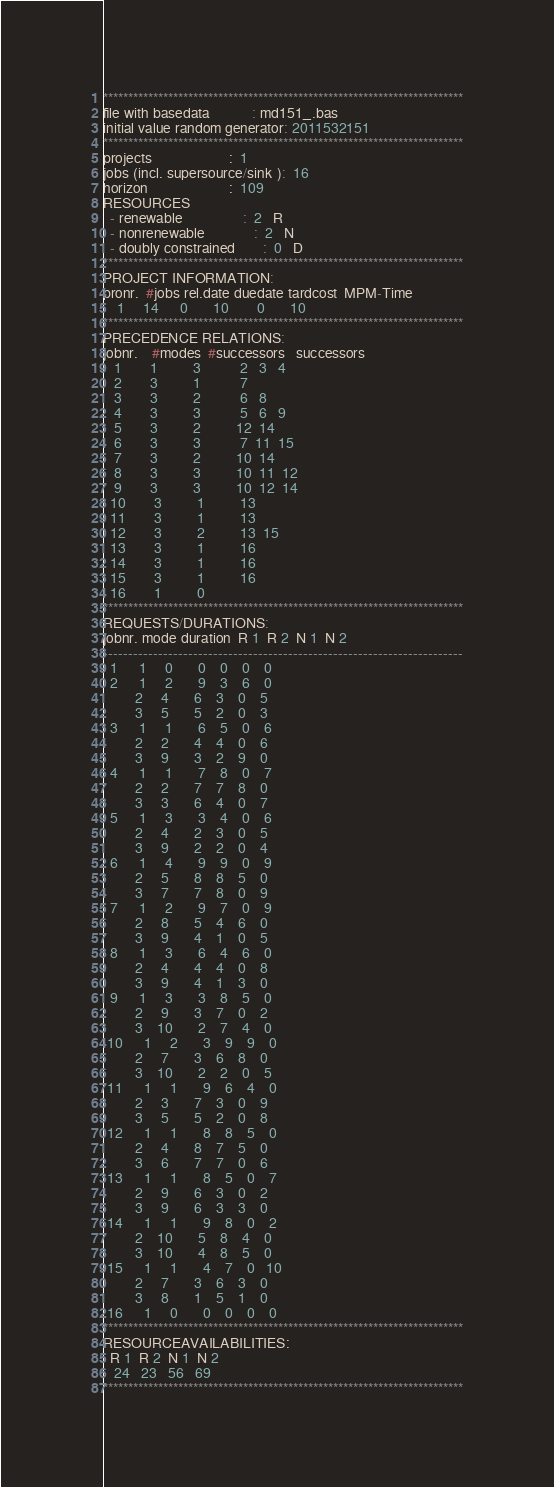Convert code to text. <code><loc_0><loc_0><loc_500><loc_500><_ObjectiveC_>************************************************************************
file with basedata            : md151_.bas
initial value random generator: 2011532151
************************************************************************
projects                      :  1
jobs (incl. supersource/sink ):  16
horizon                       :  109
RESOURCES
  - renewable                 :  2   R
  - nonrenewable              :  2   N
  - doubly constrained        :  0   D
************************************************************************
PROJECT INFORMATION:
pronr.  #jobs rel.date duedate tardcost  MPM-Time
    1     14      0       10        0       10
************************************************************************
PRECEDENCE RELATIONS:
jobnr.    #modes  #successors   successors
   1        1          3           2   3   4
   2        3          1           7
   3        3          2           6   8
   4        3          3           5   6   9
   5        3          2          12  14
   6        3          3           7  11  15
   7        3          2          10  14
   8        3          3          10  11  12
   9        3          3          10  12  14
  10        3          1          13
  11        3          1          13
  12        3          2          13  15
  13        3          1          16
  14        3          1          16
  15        3          1          16
  16        1          0        
************************************************************************
REQUESTS/DURATIONS:
jobnr. mode duration  R 1  R 2  N 1  N 2
------------------------------------------------------------------------
  1      1     0       0    0    0    0
  2      1     2       9    3    6    0
         2     4       6    3    0    5
         3     5       5    2    0    3
  3      1     1       6    5    0    6
         2     2       4    4    0    6
         3     9       3    2    9    0
  4      1     1       7    8    0    7
         2     2       7    7    8    0
         3     3       6    4    0    7
  5      1     3       3    4    0    6
         2     4       2    3    0    5
         3     9       2    2    0    4
  6      1     4       9    9    0    9
         2     5       8    8    5    0
         3     7       7    8    0    9
  7      1     2       9    7    0    9
         2     8       5    4    6    0
         3     9       4    1    0    5
  8      1     3       6    4    6    0
         2     4       4    4    0    8
         3     9       4    1    3    0
  9      1     3       3    8    5    0
         2     9       3    7    0    2
         3    10       2    7    4    0
 10      1     2       3    9    9    0
         2     7       3    6    8    0
         3    10       2    2    0    5
 11      1     1       9    6    4    0
         2     3       7    3    0    9
         3     5       5    2    0    8
 12      1     1       8    8    5    0
         2     4       8    7    5    0
         3     6       7    7    0    6
 13      1     1       8    5    0    7
         2     9       6    3    0    2
         3     9       6    3    3    0
 14      1     1       9    8    0    2
         2    10       5    8    4    0
         3    10       4    8    5    0
 15      1     1       4    7    0   10
         2     7       3    6    3    0
         3     8       1    5    1    0
 16      1     0       0    0    0    0
************************************************************************
RESOURCEAVAILABILITIES:
  R 1  R 2  N 1  N 2
   24   23   56   69
************************************************************************
</code> 